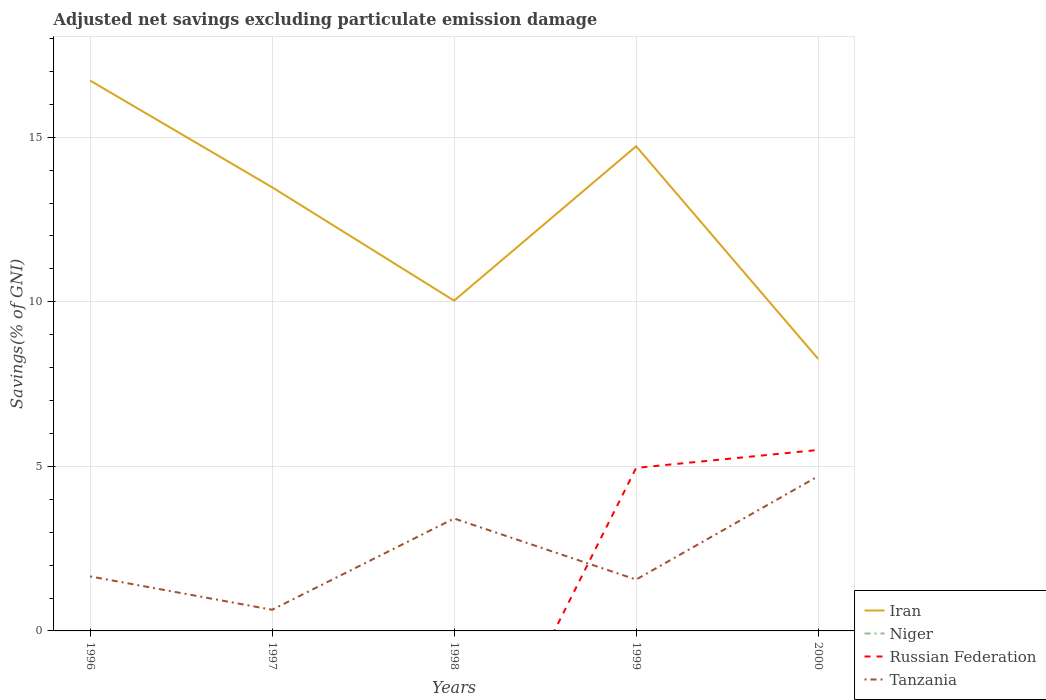How many different coloured lines are there?
Provide a succinct answer. 3. Across all years, what is the maximum adjusted net savings in Niger?
Offer a terse response. 0. What is the total adjusted net savings in Tanzania in the graph?
Keep it short and to the point. -3.14. What is the difference between the highest and the second highest adjusted net savings in Tanzania?
Your answer should be compact. 4.06. What is the difference between the highest and the lowest adjusted net savings in Niger?
Ensure brevity in your answer.  0. How many years are there in the graph?
Your answer should be very brief. 5. What is the difference between two consecutive major ticks on the Y-axis?
Ensure brevity in your answer.  5. Does the graph contain grids?
Keep it short and to the point. Yes. What is the title of the graph?
Make the answer very short. Adjusted net savings excluding particulate emission damage. Does "Uzbekistan" appear as one of the legend labels in the graph?
Offer a terse response. No. What is the label or title of the X-axis?
Offer a very short reply. Years. What is the label or title of the Y-axis?
Your answer should be compact. Savings(% of GNI). What is the Savings(% of GNI) of Iran in 1996?
Offer a very short reply. 16.72. What is the Savings(% of GNI) in Russian Federation in 1996?
Provide a succinct answer. 0. What is the Savings(% of GNI) of Tanzania in 1996?
Offer a very short reply. 1.66. What is the Savings(% of GNI) of Iran in 1997?
Make the answer very short. 13.48. What is the Savings(% of GNI) in Russian Federation in 1997?
Offer a terse response. 0. What is the Savings(% of GNI) in Tanzania in 1997?
Provide a succinct answer. 0.64. What is the Savings(% of GNI) of Iran in 1998?
Give a very brief answer. 10.04. What is the Savings(% of GNI) of Tanzania in 1998?
Ensure brevity in your answer.  3.42. What is the Savings(% of GNI) in Iran in 1999?
Provide a succinct answer. 14.73. What is the Savings(% of GNI) of Niger in 1999?
Your answer should be compact. 0. What is the Savings(% of GNI) of Russian Federation in 1999?
Your response must be concise. 4.95. What is the Savings(% of GNI) of Tanzania in 1999?
Give a very brief answer. 1.56. What is the Savings(% of GNI) in Iran in 2000?
Give a very brief answer. 8.27. What is the Savings(% of GNI) in Niger in 2000?
Your answer should be very brief. 0. What is the Savings(% of GNI) of Russian Federation in 2000?
Your response must be concise. 5.5. What is the Savings(% of GNI) in Tanzania in 2000?
Provide a succinct answer. 4.7. Across all years, what is the maximum Savings(% of GNI) in Iran?
Offer a very short reply. 16.72. Across all years, what is the maximum Savings(% of GNI) in Russian Federation?
Your answer should be compact. 5.5. Across all years, what is the maximum Savings(% of GNI) in Tanzania?
Your answer should be compact. 4.7. Across all years, what is the minimum Savings(% of GNI) of Iran?
Ensure brevity in your answer.  8.27. Across all years, what is the minimum Savings(% of GNI) in Russian Federation?
Your answer should be very brief. 0. Across all years, what is the minimum Savings(% of GNI) in Tanzania?
Provide a succinct answer. 0.64. What is the total Savings(% of GNI) of Iran in the graph?
Give a very brief answer. 63.23. What is the total Savings(% of GNI) in Russian Federation in the graph?
Your answer should be very brief. 10.45. What is the total Savings(% of GNI) in Tanzania in the graph?
Make the answer very short. 11.98. What is the difference between the Savings(% of GNI) of Iran in 1996 and that in 1997?
Ensure brevity in your answer.  3.24. What is the difference between the Savings(% of GNI) of Tanzania in 1996 and that in 1997?
Ensure brevity in your answer.  1.01. What is the difference between the Savings(% of GNI) in Iran in 1996 and that in 1998?
Your answer should be very brief. 6.69. What is the difference between the Savings(% of GNI) of Tanzania in 1996 and that in 1998?
Offer a very short reply. -1.76. What is the difference between the Savings(% of GNI) of Iran in 1996 and that in 1999?
Ensure brevity in your answer.  2. What is the difference between the Savings(% of GNI) in Tanzania in 1996 and that in 1999?
Your answer should be compact. 0.1. What is the difference between the Savings(% of GNI) in Iran in 1996 and that in 2000?
Keep it short and to the point. 8.46. What is the difference between the Savings(% of GNI) in Tanzania in 1996 and that in 2000?
Give a very brief answer. -3.04. What is the difference between the Savings(% of GNI) in Iran in 1997 and that in 1998?
Offer a very short reply. 3.44. What is the difference between the Savings(% of GNI) of Tanzania in 1997 and that in 1998?
Your answer should be very brief. -2.77. What is the difference between the Savings(% of GNI) of Iran in 1997 and that in 1999?
Provide a succinct answer. -1.25. What is the difference between the Savings(% of GNI) of Tanzania in 1997 and that in 1999?
Offer a very short reply. -0.92. What is the difference between the Savings(% of GNI) of Iran in 1997 and that in 2000?
Keep it short and to the point. 5.21. What is the difference between the Savings(% of GNI) in Tanzania in 1997 and that in 2000?
Keep it short and to the point. -4.06. What is the difference between the Savings(% of GNI) in Iran in 1998 and that in 1999?
Offer a terse response. -4.69. What is the difference between the Savings(% of GNI) of Tanzania in 1998 and that in 1999?
Give a very brief answer. 1.86. What is the difference between the Savings(% of GNI) of Iran in 1998 and that in 2000?
Keep it short and to the point. 1.77. What is the difference between the Savings(% of GNI) of Tanzania in 1998 and that in 2000?
Your answer should be compact. -1.28. What is the difference between the Savings(% of GNI) in Iran in 1999 and that in 2000?
Ensure brevity in your answer.  6.46. What is the difference between the Savings(% of GNI) of Russian Federation in 1999 and that in 2000?
Make the answer very short. -0.54. What is the difference between the Savings(% of GNI) of Tanzania in 1999 and that in 2000?
Your answer should be very brief. -3.14. What is the difference between the Savings(% of GNI) in Iran in 1996 and the Savings(% of GNI) in Tanzania in 1997?
Keep it short and to the point. 16.08. What is the difference between the Savings(% of GNI) in Iran in 1996 and the Savings(% of GNI) in Tanzania in 1998?
Provide a succinct answer. 13.31. What is the difference between the Savings(% of GNI) of Iran in 1996 and the Savings(% of GNI) of Russian Federation in 1999?
Offer a very short reply. 11.77. What is the difference between the Savings(% of GNI) of Iran in 1996 and the Savings(% of GNI) of Tanzania in 1999?
Your response must be concise. 15.16. What is the difference between the Savings(% of GNI) in Iran in 1996 and the Savings(% of GNI) in Russian Federation in 2000?
Provide a short and direct response. 11.22. What is the difference between the Savings(% of GNI) in Iran in 1996 and the Savings(% of GNI) in Tanzania in 2000?
Your answer should be very brief. 12.02. What is the difference between the Savings(% of GNI) of Iran in 1997 and the Savings(% of GNI) of Tanzania in 1998?
Your answer should be very brief. 10.06. What is the difference between the Savings(% of GNI) in Iran in 1997 and the Savings(% of GNI) in Russian Federation in 1999?
Offer a very short reply. 8.53. What is the difference between the Savings(% of GNI) of Iran in 1997 and the Savings(% of GNI) of Tanzania in 1999?
Your answer should be very brief. 11.92. What is the difference between the Savings(% of GNI) of Iran in 1997 and the Savings(% of GNI) of Russian Federation in 2000?
Provide a short and direct response. 7.98. What is the difference between the Savings(% of GNI) in Iran in 1997 and the Savings(% of GNI) in Tanzania in 2000?
Offer a very short reply. 8.78. What is the difference between the Savings(% of GNI) in Iran in 1998 and the Savings(% of GNI) in Russian Federation in 1999?
Provide a short and direct response. 5.08. What is the difference between the Savings(% of GNI) in Iran in 1998 and the Savings(% of GNI) in Tanzania in 1999?
Your answer should be compact. 8.48. What is the difference between the Savings(% of GNI) in Iran in 1998 and the Savings(% of GNI) in Russian Federation in 2000?
Provide a short and direct response. 4.54. What is the difference between the Savings(% of GNI) of Iran in 1998 and the Savings(% of GNI) of Tanzania in 2000?
Your answer should be compact. 5.34. What is the difference between the Savings(% of GNI) in Iran in 1999 and the Savings(% of GNI) in Russian Federation in 2000?
Your response must be concise. 9.23. What is the difference between the Savings(% of GNI) in Iran in 1999 and the Savings(% of GNI) in Tanzania in 2000?
Your answer should be compact. 10.03. What is the difference between the Savings(% of GNI) of Russian Federation in 1999 and the Savings(% of GNI) of Tanzania in 2000?
Offer a terse response. 0.25. What is the average Savings(% of GNI) of Iran per year?
Keep it short and to the point. 12.65. What is the average Savings(% of GNI) in Russian Federation per year?
Provide a short and direct response. 2.09. What is the average Savings(% of GNI) of Tanzania per year?
Provide a succinct answer. 2.4. In the year 1996, what is the difference between the Savings(% of GNI) in Iran and Savings(% of GNI) in Tanzania?
Provide a short and direct response. 15.07. In the year 1997, what is the difference between the Savings(% of GNI) in Iran and Savings(% of GNI) in Tanzania?
Your answer should be compact. 12.84. In the year 1998, what is the difference between the Savings(% of GNI) in Iran and Savings(% of GNI) in Tanzania?
Keep it short and to the point. 6.62. In the year 1999, what is the difference between the Savings(% of GNI) in Iran and Savings(% of GNI) in Russian Federation?
Your answer should be very brief. 9.77. In the year 1999, what is the difference between the Savings(% of GNI) of Iran and Savings(% of GNI) of Tanzania?
Your answer should be compact. 13.17. In the year 1999, what is the difference between the Savings(% of GNI) in Russian Federation and Savings(% of GNI) in Tanzania?
Your response must be concise. 3.39. In the year 2000, what is the difference between the Savings(% of GNI) of Iran and Savings(% of GNI) of Russian Federation?
Provide a succinct answer. 2.77. In the year 2000, what is the difference between the Savings(% of GNI) in Iran and Savings(% of GNI) in Tanzania?
Provide a succinct answer. 3.57. In the year 2000, what is the difference between the Savings(% of GNI) in Russian Federation and Savings(% of GNI) in Tanzania?
Your answer should be very brief. 0.8. What is the ratio of the Savings(% of GNI) of Iran in 1996 to that in 1997?
Your response must be concise. 1.24. What is the ratio of the Savings(% of GNI) of Tanzania in 1996 to that in 1997?
Give a very brief answer. 2.57. What is the ratio of the Savings(% of GNI) in Iran in 1996 to that in 1998?
Keep it short and to the point. 1.67. What is the ratio of the Savings(% of GNI) of Tanzania in 1996 to that in 1998?
Make the answer very short. 0.48. What is the ratio of the Savings(% of GNI) in Iran in 1996 to that in 1999?
Your answer should be compact. 1.14. What is the ratio of the Savings(% of GNI) in Tanzania in 1996 to that in 1999?
Your answer should be very brief. 1.06. What is the ratio of the Savings(% of GNI) of Iran in 1996 to that in 2000?
Offer a very short reply. 2.02. What is the ratio of the Savings(% of GNI) of Tanzania in 1996 to that in 2000?
Give a very brief answer. 0.35. What is the ratio of the Savings(% of GNI) of Iran in 1997 to that in 1998?
Provide a short and direct response. 1.34. What is the ratio of the Savings(% of GNI) of Tanzania in 1997 to that in 1998?
Your response must be concise. 0.19. What is the ratio of the Savings(% of GNI) in Iran in 1997 to that in 1999?
Provide a short and direct response. 0.92. What is the ratio of the Savings(% of GNI) in Tanzania in 1997 to that in 1999?
Ensure brevity in your answer.  0.41. What is the ratio of the Savings(% of GNI) of Iran in 1997 to that in 2000?
Offer a very short reply. 1.63. What is the ratio of the Savings(% of GNI) of Tanzania in 1997 to that in 2000?
Keep it short and to the point. 0.14. What is the ratio of the Savings(% of GNI) of Iran in 1998 to that in 1999?
Give a very brief answer. 0.68. What is the ratio of the Savings(% of GNI) of Tanzania in 1998 to that in 1999?
Offer a terse response. 2.19. What is the ratio of the Savings(% of GNI) of Iran in 1998 to that in 2000?
Offer a very short reply. 1.21. What is the ratio of the Savings(% of GNI) of Tanzania in 1998 to that in 2000?
Provide a succinct answer. 0.73. What is the ratio of the Savings(% of GNI) in Iran in 1999 to that in 2000?
Ensure brevity in your answer.  1.78. What is the ratio of the Savings(% of GNI) of Russian Federation in 1999 to that in 2000?
Your answer should be very brief. 0.9. What is the ratio of the Savings(% of GNI) in Tanzania in 1999 to that in 2000?
Your answer should be compact. 0.33. What is the difference between the highest and the second highest Savings(% of GNI) in Iran?
Offer a very short reply. 2. What is the difference between the highest and the second highest Savings(% of GNI) in Tanzania?
Keep it short and to the point. 1.28. What is the difference between the highest and the lowest Savings(% of GNI) of Iran?
Give a very brief answer. 8.46. What is the difference between the highest and the lowest Savings(% of GNI) of Russian Federation?
Provide a short and direct response. 5.5. What is the difference between the highest and the lowest Savings(% of GNI) of Tanzania?
Keep it short and to the point. 4.06. 